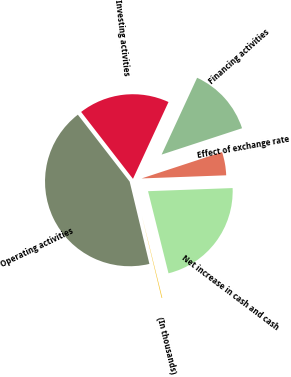Convert chart. <chart><loc_0><loc_0><loc_500><loc_500><pie_chart><fcel>(In thousands)<fcel>Operating activities<fcel>Investing activities<fcel>Financing activities<fcel>Effect of exchange rate<fcel>Net increase in cash and cash<nl><fcel>0.14%<fcel>43.26%<fcel>17.38%<fcel>13.07%<fcel>4.45%<fcel>21.7%<nl></chart> 